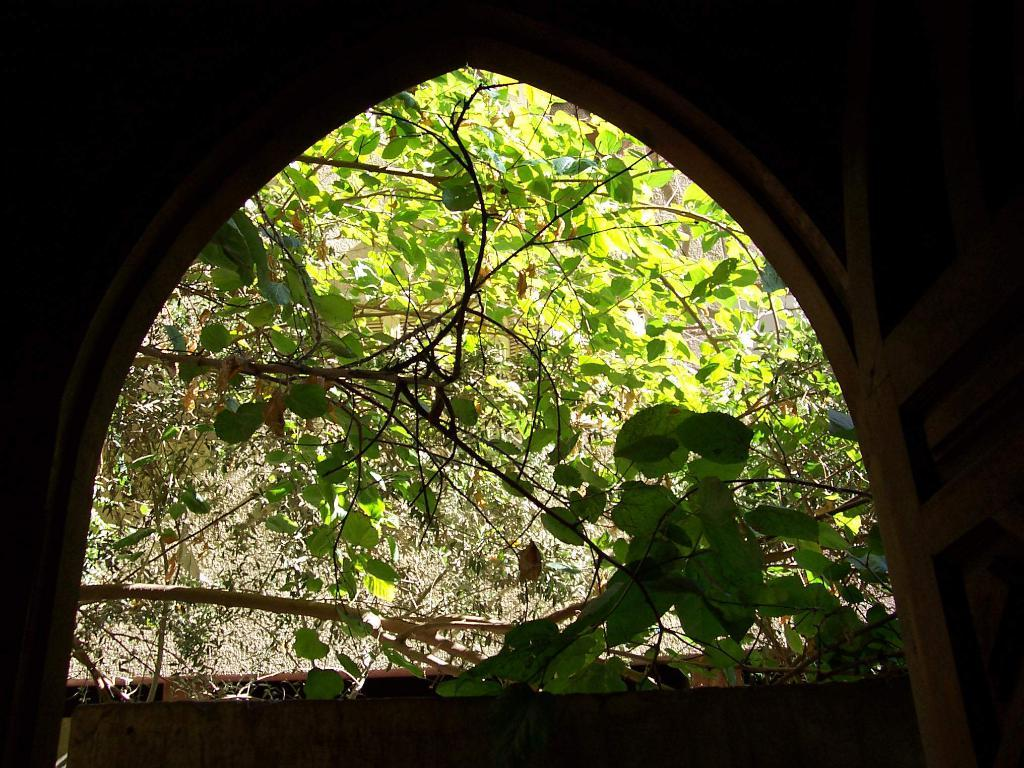What is the main subject in the center of the image? There is a wall in the center of the image, along with a few other objects. What can be seen in the background of the image? There are trees, plants, and a wooden object in the background of the image, along with a few other objects. What type of plastic material is used to create the attraction in the image? There is no attraction present in the image, and therefore no plastic material can be identified. 